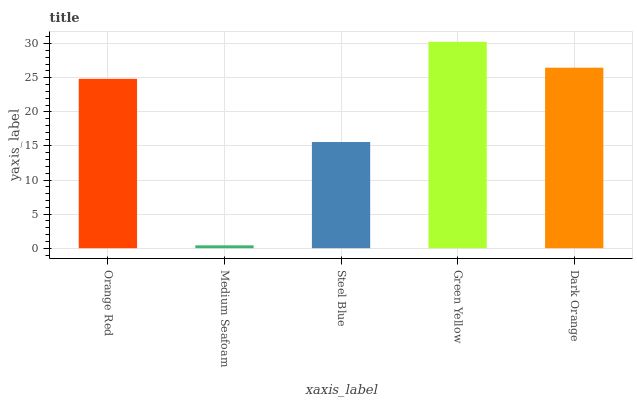Is Medium Seafoam the minimum?
Answer yes or no. Yes. Is Green Yellow the maximum?
Answer yes or no. Yes. Is Steel Blue the minimum?
Answer yes or no. No. Is Steel Blue the maximum?
Answer yes or no. No. Is Steel Blue greater than Medium Seafoam?
Answer yes or no. Yes. Is Medium Seafoam less than Steel Blue?
Answer yes or no. Yes. Is Medium Seafoam greater than Steel Blue?
Answer yes or no. No. Is Steel Blue less than Medium Seafoam?
Answer yes or no. No. Is Orange Red the high median?
Answer yes or no. Yes. Is Orange Red the low median?
Answer yes or no. Yes. Is Green Yellow the high median?
Answer yes or no. No. Is Dark Orange the low median?
Answer yes or no. No. 